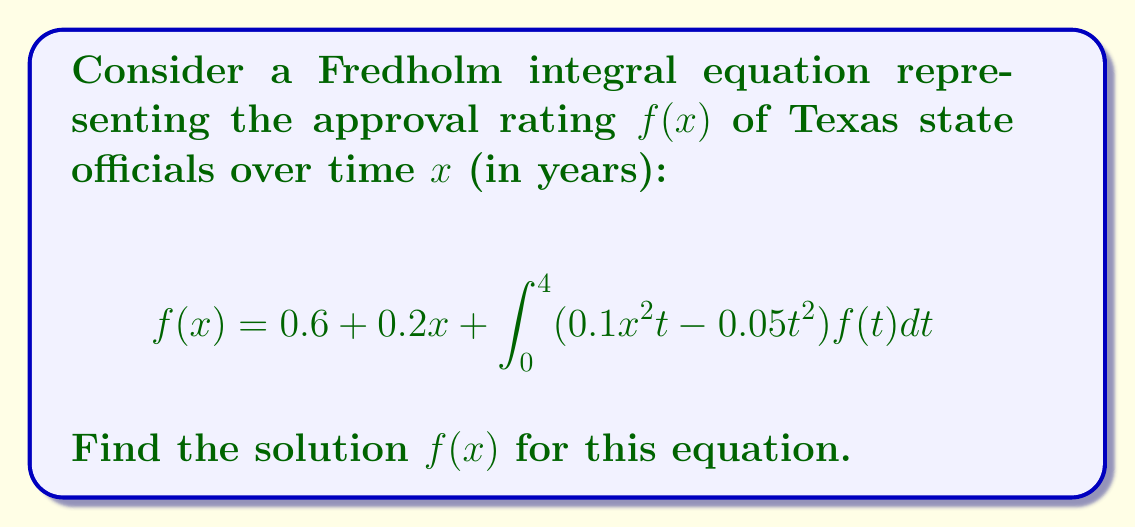Solve this math problem. To solve this Fredholm integral equation, we'll follow these steps:

1) First, we assume that the solution has the form:
   $$f(x) = a + bx$$
   where $a$ and $b$ are constants to be determined.

2) Substitute this form into the original equation:
   $$(a + bx) = 0.6 + 0.2x + \int_0^4 (0.1x^2t - 0.05t^2)(a + bt)dt$$

3) Evaluate the integral:
   $$\int_0^4 (0.1x^2t - 0.05t^2)(a + bt)dt = \int_0^4 (0.1ax^2t + 0.1bx^2t^2 - 0.05at^2 - 0.05bt^3)dt$$
   $$= [0.05ax^2t^2 + \frac{1}{3}0.1bx^2t^3 - \frac{1}{3}0.05at^3 - \frac{1}{4}0.05bt^4]_0^4$$
   $$= 0.8ax^2 + \frac{64}{15}bx^2 - \frac{16}{3}a - \frac{64}{5}b$$

4) Substitute this result back into the equation:
   $$a + bx = 0.6 + 0.2x + 0.8ax^2 + \frac{64}{15}bx^2 - \frac{16}{3}a - \frac{64}{5}b$$

5) Equate coefficients of $x^2$, $x$, and constant terms:
   $x^2: 0 = 0.8a + \frac{64}{15}b$
   $x: b = 0.2$
   constant: $a = 0.6 - \frac{16}{3}a - \frac{64}{5}b$

6) From the second equation, we know $b = 0.2$. Substitute this into the first equation:
   $$0 = 0.8a + \frac{64}{15}(0.2)$$
   $$0 = 0.8a + 0.8533...$$
   $$a = -1.0667...$$

7) Verify this value of $a$ satisfies the constant term equation:
   $$-1.0667... = 0.6 - \frac{16}{3}(-1.0667...) - \frac{64}{5}(0.2)$$
   $$-1.0667... = 0.6 + 5.6889... - 2.56$$
   $$-1.0667... = 3.7289... - 4.7956...$$
   $$-1.0667... ≈ -1.0667...$$

Therefore, the solution is confirmed.
Answer: $f(x) = -1.0667 + 0.2x$ 